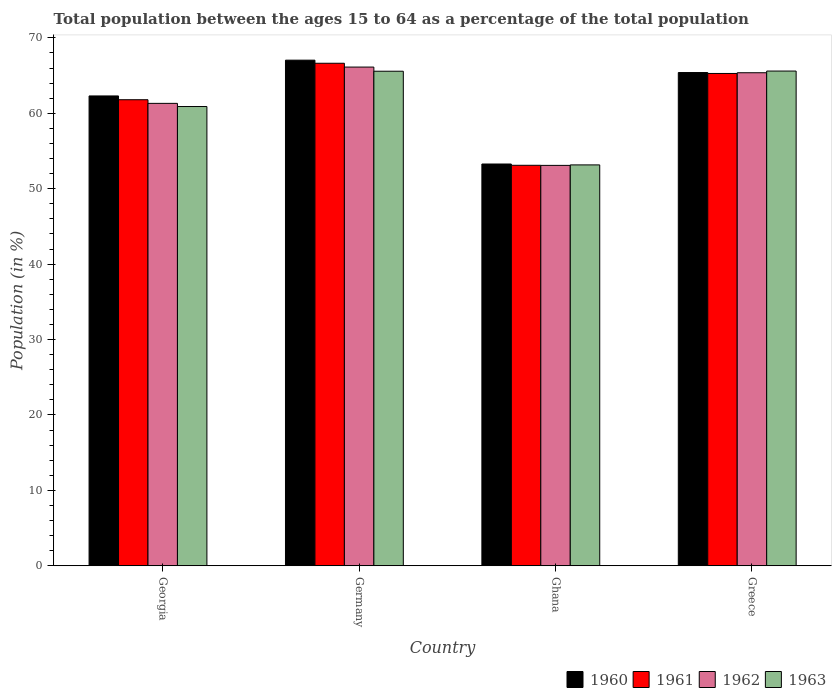Are the number of bars per tick equal to the number of legend labels?
Make the answer very short. Yes. Are the number of bars on each tick of the X-axis equal?
Your answer should be very brief. Yes. How many bars are there on the 1st tick from the left?
Keep it short and to the point. 4. How many bars are there on the 4th tick from the right?
Make the answer very short. 4. What is the label of the 2nd group of bars from the left?
Ensure brevity in your answer.  Germany. What is the percentage of the population ages 15 to 64 in 1962 in Greece?
Keep it short and to the point. 65.38. Across all countries, what is the maximum percentage of the population ages 15 to 64 in 1963?
Offer a very short reply. 65.61. Across all countries, what is the minimum percentage of the population ages 15 to 64 in 1960?
Give a very brief answer. 53.28. In which country was the percentage of the population ages 15 to 64 in 1963 maximum?
Give a very brief answer. Greece. In which country was the percentage of the population ages 15 to 64 in 1962 minimum?
Offer a very short reply. Ghana. What is the total percentage of the population ages 15 to 64 in 1962 in the graph?
Provide a succinct answer. 245.93. What is the difference between the percentage of the population ages 15 to 64 in 1963 in Georgia and that in Greece?
Provide a succinct answer. -4.7. What is the difference between the percentage of the population ages 15 to 64 in 1960 in Ghana and the percentage of the population ages 15 to 64 in 1961 in Georgia?
Ensure brevity in your answer.  -8.52. What is the average percentage of the population ages 15 to 64 in 1961 per country?
Your answer should be very brief. 61.71. What is the difference between the percentage of the population ages 15 to 64 of/in 1963 and percentage of the population ages 15 to 64 of/in 1962 in Ghana?
Your answer should be very brief. 0.06. In how many countries, is the percentage of the population ages 15 to 64 in 1963 greater than 60?
Keep it short and to the point. 3. What is the ratio of the percentage of the population ages 15 to 64 in 1963 in Germany to that in Ghana?
Keep it short and to the point. 1.23. Is the percentage of the population ages 15 to 64 in 1961 in Georgia less than that in Germany?
Make the answer very short. Yes. Is the difference between the percentage of the population ages 15 to 64 in 1963 in Ghana and Greece greater than the difference between the percentage of the population ages 15 to 64 in 1962 in Ghana and Greece?
Provide a short and direct response. No. What is the difference between the highest and the second highest percentage of the population ages 15 to 64 in 1962?
Provide a short and direct response. -0.75. What is the difference between the highest and the lowest percentage of the population ages 15 to 64 in 1961?
Offer a terse response. 13.53. Is the sum of the percentage of the population ages 15 to 64 in 1961 in Ghana and Greece greater than the maximum percentage of the population ages 15 to 64 in 1963 across all countries?
Give a very brief answer. Yes. Is it the case that in every country, the sum of the percentage of the population ages 15 to 64 in 1961 and percentage of the population ages 15 to 64 in 1962 is greater than the sum of percentage of the population ages 15 to 64 in 1963 and percentage of the population ages 15 to 64 in 1960?
Your answer should be very brief. No. What does the 1st bar from the left in Germany represents?
Your response must be concise. 1960. How many bars are there?
Give a very brief answer. 16. How many countries are there in the graph?
Offer a terse response. 4. What is the difference between two consecutive major ticks on the Y-axis?
Offer a terse response. 10. Does the graph contain grids?
Offer a terse response. No. Where does the legend appear in the graph?
Your answer should be very brief. Bottom right. How many legend labels are there?
Offer a very short reply. 4. What is the title of the graph?
Ensure brevity in your answer.  Total population between the ages 15 to 64 as a percentage of the total population. What is the label or title of the X-axis?
Keep it short and to the point. Country. What is the Population (in %) of 1960 in Georgia?
Your response must be concise. 62.31. What is the Population (in %) in 1961 in Georgia?
Offer a terse response. 61.8. What is the Population (in %) in 1962 in Georgia?
Ensure brevity in your answer.  61.32. What is the Population (in %) in 1963 in Georgia?
Provide a succinct answer. 60.9. What is the Population (in %) in 1960 in Germany?
Provide a short and direct response. 67.05. What is the Population (in %) of 1961 in Germany?
Your response must be concise. 66.64. What is the Population (in %) of 1962 in Germany?
Your answer should be compact. 66.13. What is the Population (in %) in 1963 in Germany?
Provide a short and direct response. 65.58. What is the Population (in %) in 1960 in Ghana?
Give a very brief answer. 53.28. What is the Population (in %) of 1961 in Ghana?
Offer a very short reply. 53.11. What is the Population (in %) of 1962 in Ghana?
Your answer should be very brief. 53.1. What is the Population (in %) of 1963 in Ghana?
Keep it short and to the point. 53.16. What is the Population (in %) in 1960 in Greece?
Offer a terse response. 65.41. What is the Population (in %) in 1961 in Greece?
Make the answer very short. 65.29. What is the Population (in %) of 1962 in Greece?
Make the answer very short. 65.38. What is the Population (in %) in 1963 in Greece?
Your answer should be very brief. 65.61. Across all countries, what is the maximum Population (in %) in 1960?
Keep it short and to the point. 67.05. Across all countries, what is the maximum Population (in %) of 1961?
Provide a succinct answer. 66.64. Across all countries, what is the maximum Population (in %) of 1962?
Give a very brief answer. 66.13. Across all countries, what is the maximum Population (in %) in 1963?
Offer a very short reply. 65.61. Across all countries, what is the minimum Population (in %) of 1960?
Provide a short and direct response. 53.28. Across all countries, what is the minimum Population (in %) of 1961?
Make the answer very short. 53.11. Across all countries, what is the minimum Population (in %) in 1962?
Provide a short and direct response. 53.1. Across all countries, what is the minimum Population (in %) in 1963?
Your answer should be compact. 53.16. What is the total Population (in %) in 1960 in the graph?
Offer a very short reply. 248.05. What is the total Population (in %) in 1961 in the graph?
Make the answer very short. 246.84. What is the total Population (in %) in 1962 in the graph?
Give a very brief answer. 245.93. What is the total Population (in %) in 1963 in the graph?
Your response must be concise. 245.25. What is the difference between the Population (in %) in 1960 in Georgia and that in Germany?
Give a very brief answer. -4.74. What is the difference between the Population (in %) in 1961 in Georgia and that in Germany?
Offer a very short reply. -4.84. What is the difference between the Population (in %) in 1962 in Georgia and that in Germany?
Give a very brief answer. -4.81. What is the difference between the Population (in %) of 1963 in Georgia and that in Germany?
Ensure brevity in your answer.  -4.68. What is the difference between the Population (in %) in 1960 in Georgia and that in Ghana?
Offer a terse response. 9.03. What is the difference between the Population (in %) of 1961 in Georgia and that in Ghana?
Your answer should be very brief. 8.69. What is the difference between the Population (in %) in 1962 in Georgia and that in Ghana?
Offer a very short reply. 8.23. What is the difference between the Population (in %) in 1963 in Georgia and that in Ghana?
Make the answer very short. 7.74. What is the difference between the Population (in %) in 1960 in Georgia and that in Greece?
Give a very brief answer. -3.1. What is the difference between the Population (in %) of 1961 in Georgia and that in Greece?
Your answer should be very brief. -3.48. What is the difference between the Population (in %) of 1962 in Georgia and that in Greece?
Offer a terse response. -4.06. What is the difference between the Population (in %) in 1963 in Georgia and that in Greece?
Give a very brief answer. -4.7. What is the difference between the Population (in %) in 1960 in Germany and that in Ghana?
Offer a very short reply. 13.77. What is the difference between the Population (in %) of 1961 in Germany and that in Ghana?
Offer a very short reply. 13.53. What is the difference between the Population (in %) of 1962 in Germany and that in Ghana?
Make the answer very short. 13.04. What is the difference between the Population (in %) of 1963 in Germany and that in Ghana?
Make the answer very short. 12.42. What is the difference between the Population (in %) of 1960 in Germany and that in Greece?
Provide a short and direct response. 1.64. What is the difference between the Population (in %) in 1961 in Germany and that in Greece?
Give a very brief answer. 1.35. What is the difference between the Population (in %) of 1962 in Germany and that in Greece?
Provide a short and direct response. 0.75. What is the difference between the Population (in %) of 1963 in Germany and that in Greece?
Your answer should be very brief. -0.02. What is the difference between the Population (in %) in 1960 in Ghana and that in Greece?
Your answer should be very brief. -12.13. What is the difference between the Population (in %) of 1961 in Ghana and that in Greece?
Your response must be concise. -12.18. What is the difference between the Population (in %) in 1962 in Ghana and that in Greece?
Make the answer very short. -12.29. What is the difference between the Population (in %) of 1963 in Ghana and that in Greece?
Provide a succinct answer. -12.44. What is the difference between the Population (in %) of 1960 in Georgia and the Population (in %) of 1961 in Germany?
Offer a terse response. -4.33. What is the difference between the Population (in %) in 1960 in Georgia and the Population (in %) in 1962 in Germany?
Offer a terse response. -3.83. What is the difference between the Population (in %) in 1960 in Georgia and the Population (in %) in 1963 in Germany?
Your response must be concise. -3.28. What is the difference between the Population (in %) of 1961 in Georgia and the Population (in %) of 1962 in Germany?
Provide a short and direct response. -4.33. What is the difference between the Population (in %) of 1961 in Georgia and the Population (in %) of 1963 in Germany?
Your answer should be compact. -3.78. What is the difference between the Population (in %) in 1962 in Georgia and the Population (in %) in 1963 in Germany?
Keep it short and to the point. -4.26. What is the difference between the Population (in %) of 1960 in Georgia and the Population (in %) of 1961 in Ghana?
Make the answer very short. 9.2. What is the difference between the Population (in %) of 1960 in Georgia and the Population (in %) of 1962 in Ghana?
Your response must be concise. 9.21. What is the difference between the Population (in %) of 1960 in Georgia and the Population (in %) of 1963 in Ghana?
Offer a terse response. 9.15. What is the difference between the Population (in %) of 1961 in Georgia and the Population (in %) of 1962 in Ghana?
Offer a very short reply. 8.71. What is the difference between the Population (in %) of 1961 in Georgia and the Population (in %) of 1963 in Ghana?
Give a very brief answer. 8.64. What is the difference between the Population (in %) of 1962 in Georgia and the Population (in %) of 1963 in Ghana?
Offer a very short reply. 8.16. What is the difference between the Population (in %) in 1960 in Georgia and the Population (in %) in 1961 in Greece?
Your answer should be very brief. -2.98. What is the difference between the Population (in %) of 1960 in Georgia and the Population (in %) of 1962 in Greece?
Offer a very short reply. -3.08. What is the difference between the Population (in %) in 1960 in Georgia and the Population (in %) in 1963 in Greece?
Ensure brevity in your answer.  -3.3. What is the difference between the Population (in %) in 1961 in Georgia and the Population (in %) in 1962 in Greece?
Your answer should be compact. -3.58. What is the difference between the Population (in %) in 1961 in Georgia and the Population (in %) in 1963 in Greece?
Your answer should be very brief. -3.8. What is the difference between the Population (in %) of 1962 in Georgia and the Population (in %) of 1963 in Greece?
Offer a terse response. -4.28. What is the difference between the Population (in %) of 1960 in Germany and the Population (in %) of 1961 in Ghana?
Offer a terse response. 13.94. What is the difference between the Population (in %) in 1960 in Germany and the Population (in %) in 1962 in Ghana?
Give a very brief answer. 13.95. What is the difference between the Population (in %) of 1960 in Germany and the Population (in %) of 1963 in Ghana?
Your answer should be compact. 13.89. What is the difference between the Population (in %) in 1961 in Germany and the Population (in %) in 1962 in Ghana?
Offer a terse response. 13.54. What is the difference between the Population (in %) of 1961 in Germany and the Population (in %) of 1963 in Ghana?
Offer a very short reply. 13.48. What is the difference between the Population (in %) of 1962 in Germany and the Population (in %) of 1963 in Ghana?
Your answer should be compact. 12.97. What is the difference between the Population (in %) in 1960 in Germany and the Population (in %) in 1961 in Greece?
Provide a succinct answer. 1.76. What is the difference between the Population (in %) in 1960 in Germany and the Population (in %) in 1962 in Greece?
Give a very brief answer. 1.67. What is the difference between the Population (in %) of 1960 in Germany and the Population (in %) of 1963 in Greece?
Offer a terse response. 1.45. What is the difference between the Population (in %) of 1961 in Germany and the Population (in %) of 1962 in Greece?
Provide a succinct answer. 1.26. What is the difference between the Population (in %) of 1961 in Germany and the Population (in %) of 1963 in Greece?
Provide a short and direct response. 1.03. What is the difference between the Population (in %) in 1962 in Germany and the Population (in %) in 1963 in Greece?
Provide a short and direct response. 0.53. What is the difference between the Population (in %) in 1960 in Ghana and the Population (in %) in 1961 in Greece?
Keep it short and to the point. -12.01. What is the difference between the Population (in %) in 1960 in Ghana and the Population (in %) in 1962 in Greece?
Keep it short and to the point. -12.1. What is the difference between the Population (in %) in 1960 in Ghana and the Population (in %) in 1963 in Greece?
Make the answer very short. -12.33. What is the difference between the Population (in %) of 1961 in Ghana and the Population (in %) of 1962 in Greece?
Make the answer very short. -12.27. What is the difference between the Population (in %) in 1961 in Ghana and the Population (in %) in 1963 in Greece?
Make the answer very short. -12.5. What is the difference between the Population (in %) in 1962 in Ghana and the Population (in %) in 1963 in Greece?
Give a very brief answer. -12.51. What is the average Population (in %) in 1960 per country?
Your response must be concise. 62.01. What is the average Population (in %) of 1961 per country?
Ensure brevity in your answer.  61.71. What is the average Population (in %) in 1962 per country?
Make the answer very short. 61.48. What is the average Population (in %) in 1963 per country?
Offer a very short reply. 61.31. What is the difference between the Population (in %) of 1960 and Population (in %) of 1961 in Georgia?
Your answer should be compact. 0.5. What is the difference between the Population (in %) in 1960 and Population (in %) in 1962 in Georgia?
Your answer should be very brief. 0.98. What is the difference between the Population (in %) of 1960 and Population (in %) of 1963 in Georgia?
Your answer should be compact. 1.4. What is the difference between the Population (in %) in 1961 and Population (in %) in 1962 in Georgia?
Provide a succinct answer. 0.48. What is the difference between the Population (in %) of 1961 and Population (in %) of 1963 in Georgia?
Keep it short and to the point. 0.9. What is the difference between the Population (in %) of 1962 and Population (in %) of 1963 in Georgia?
Ensure brevity in your answer.  0.42. What is the difference between the Population (in %) in 1960 and Population (in %) in 1961 in Germany?
Make the answer very short. 0.41. What is the difference between the Population (in %) in 1960 and Population (in %) in 1962 in Germany?
Your answer should be compact. 0.92. What is the difference between the Population (in %) of 1960 and Population (in %) of 1963 in Germany?
Your response must be concise. 1.47. What is the difference between the Population (in %) of 1961 and Population (in %) of 1962 in Germany?
Provide a short and direct response. 0.51. What is the difference between the Population (in %) of 1961 and Population (in %) of 1963 in Germany?
Provide a short and direct response. 1.06. What is the difference between the Population (in %) in 1962 and Population (in %) in 1963 in Germany?
Ensure brevity in your answer.  0.55. What is the difference between the Population (in %) in 1960 and Population (in %) in 1961 in Ghana?
Provide a short and direct response. 0.17. What is the difference between the Population (in %) of 1960 and Population (in %) of 1962 in Ghana?
Your response must be concise. 0.18. What is the difference between the Population (in %) of 1960 and Population (in %) of 1963 in Ghana?
Provide a succinct answer. 0.12. What is the difference between the Population (in %) in 1961 and Population (in %) in 1962 in Ghana?
Provide a short and direct response. 0.01. What is the difference between the Population (in %) of 1961 and Population (in %) of 1963 in Ghana?
Provide a short and direct response. -0.05. What is the difference between the Population (in %) in 1962 and Population (in %) in 1963 in Ghana?
Provide a succinct answer. -0.06. What is the difference between the Population (in %) in 1960 and Population (in %) in 1961 in Greece?
Your response must be concise. 0.12. What is the difference between the Population (in %) of 1960 and Population (in %) of 1962 in Greece?
Your answer should be very brief. 0.03. What is the difference between the Population (in %) of 1960 and Population (in %) of 1963 in Greece?
Your answer should be compact. -0.2. What is the difference between the Population (in %) in 1961 and Population (in %) in 1962 in Greece?
Offer a very short reply. -0.1. What is the difference between the Population (in %) of 1961 and Population (in %) of 1963 in Greece?
Offer a very short reply. -0.32. What is the difference between the Population (in %) of 1962 and Population (in %) of 1963 in Greece?
Provide a short and direct response. -0.22. What is the ratio of the Population (in %) in 1960 in Georgia to that in Germany?
Your response must be concise. 0.93. What is the ratio of the Population (in %) of 1961 in Georgia to that in Germany?
Your answer should be very brief. 0.93. What is the ratio of the Population (in %) in 1962 in Georgia to that in Germany?
Provide a short and direct response. 0.93. What is the ratio of the Population (in %) of 1963 in Georgia to that in Germany?
Provide a short and direct response. 0.93. What is the ratio of the Population (in %) in 1960 in Georgia to that in Ghana?
Your answer should be compact. 1.17. What is the ratio of the Population (in %) in 1961 in Georgia to that in Ghana?
Provide a short and direct response. 1.16. What is the ratio of the Population (in %) in 1962 in Georgia to that in Ghana?
Make the answer very short. 1.15. What is the ratio of the Population (in %) in 1963 in Georgia to that in Ghana?
Keep it short and to the point. 1.15. What is the ratio of the Population (in %) of 1960 in Georgia to that in Greece?
Provide a succinct answer. 0.95. What is the ratio of the Population (in %) of 1961 in Georgia to that in Greece?
Provide a short and direct response. 0.95. What is the ratio of the Population (in %) in 1962 in Georgia to that in Greece?
Keep it short and to the point. 0.94. What is the ratio of the Population (in %) in 1963 in Georgia to that in Greece?
Provide a succinct answer. 0.93. What is the ratio of the Population (in %) of 1960 in Germany to that in Ghana?
Offer a terse response. 1.26. What is the ratio of the Population (in %) in 1961 in Germany to that in Ghana?
Offer a very short reply. 1.25. What is the ratio of the Population (in %) in 1962 in Germany to that in Ghana?
Provide a succinct answer. 1.25. What is the ratio of the Population (in %) of 1963 in Germany to that in Ghana?
Give a very brief answer. 1.23. What is the ratio of the Population (in %) of 1960 in Germany to that in Greece?
Your answer should be very brief. 1.03. What is the ratio of the Population (in %) of 1961 in Germany to that in Greece?
Keep it short and to the point. 1.02. What is the ratio of the Population (in %) of 1962 in Germany to that in Greece?
Offer a terse response. 1.01. What is the ratio of the Population (in %) of 1963 in Germany to that in Greece?
Provide a short and direct response. 1. What is the ratio of the Population (in %) in 1960 in Ghana to that in Greece?
Provide a succinct answer. 0.81. What is the ratio of the Population (in %) in 1961 in Ghana to that in Greece?
Your response must be concise. 0.81. What is the ratio of the Population (in %) in 1962 in Ghana to that in Greece?
Give a very brief answer. 0.81. What is the ratio of the Population (in %) in 1963 in Ghana to that in Greece?
Give a very brief answer. 0.81. What is the difference between the highest and the second highest Population (in %) in 1960?
Provide a succinct answer. 1.64. What is the difference between the highest and the second highest Population (in %) in 1961?
Your response must be concise. 1.35. What is the difference between the highest and the second highest Population (in %) of 1962?
Provide a short and direct response. 0.75. What is the difference between the highest and the second highest Population (in %) of 1963?
Ensure brevity in your answer.  0.02. What is the difference between the highest and the lowest Population (in %) in 1960?
Offer a terse response. 13.77. What is the difference between the highest and the lowest Population (in %) of 1961?
Provide a succinct answer. 13.53. What is the difference between the highest and the lowest Population (in %) in 1962?
Provide a succinct answer. 13.04. What is the difference between the highest and the lowest Population (in %) of 1963?
Your response must be concise. 12.44. 